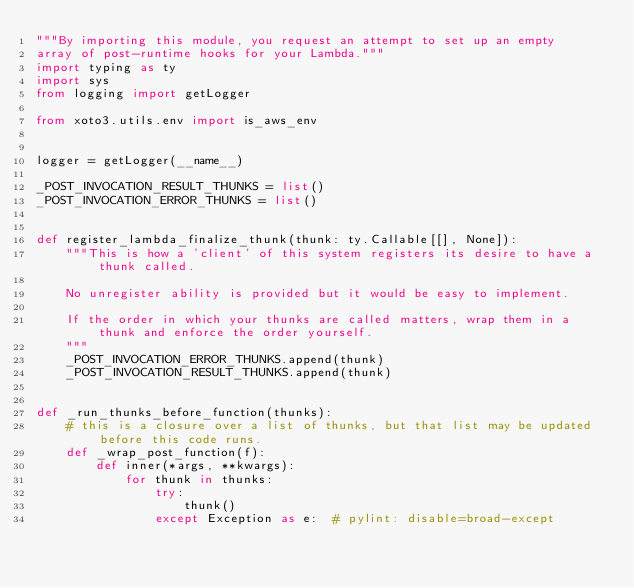<code> <loc_0><loc_0><loc_500><loc_500><_Python_>"""By importing this module, you request an attempt to set up an empty
array of post-runtime hooks for your Lambda."""
import typing as ty
import sys
from logging import getLogger

from xoto3.utils.env import is_aws_env


logger = getLogger(__name__)

_POST_INVOCATION_RESULT_THUNKS = list()
_POST_INVOCATION_ERROR_THUNKS = list()


def register_lambda_finalize_thunk(thunk: ty.Callable[[], None]):
    """This is how a 'client' of this system registers its desire to have a thunk called.

    No unregister ability is provided but it would be easy to implement.

    If the order in which your thunks are called matters, wrap them in a thunk and enforce the order yourself.
    """
    _POST_INVOCATION_ERROR_THUNKS.append(thunk)
    _POST_INVOCATION_RESULT_THUNKS.append(thunk)


def _run_thunks_before_function(thunks):
    # this is a closure over a list of thunks, but that list may be updated before this code runs.
    def _wrap_post_function(f):
        def inner(*args, **kwargs):
            for thunk in thunks:
                try:
                    thunk()
                except Exception as e:  # pylint: disable=broad-except</code> 